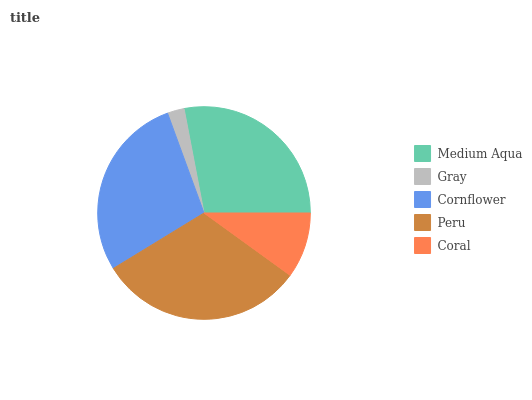Is Gray the minimum?
Answer yes or no. Yes. Is Peru the maximum?
Answer yes or no. Yes. Is Cornflower the minimum?
Answer yes or no. No. Is Cornflower the maximum?
Answer yes or no. No. Is Cornflower greater than Gray?
Answer yes or no. Yes. Is Gray less than Cornflower?
Answer yes or no. Yes. Is Gray greater than Cornflower?
Answer yes or no. No. Is Cornflower less than Gray?
Answer yes or no. No. Is Medium Aqua the high median?
Answer yes or no. Yes. Is Medium Aqua the low median?
Answer yes or no. Yes. Is Coral the high median?
Answer yes or no. No. Is Cornflower the low median?
Answer yes or no. No. 